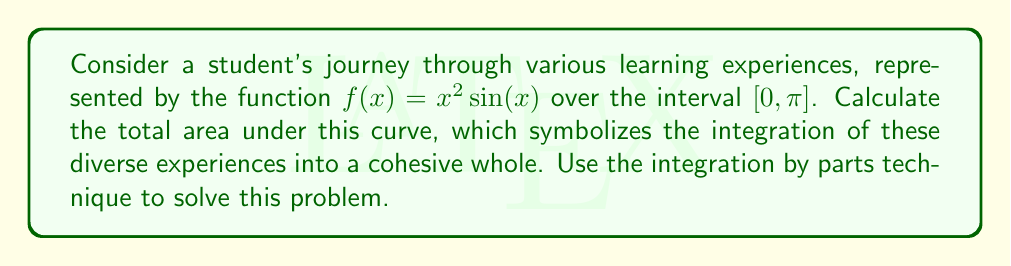Help me with this question. To solve this problem, we'll use integration by parts. The formula for integration by parts is:

$$\int u \frac{dv}{dx} dx = uv - \int v \frac{du}{dx} dx$$

Let's choose:
$u = x^2$ and $\frac{dv}{dx} = \sin(x)$

Then:
$\frac{du}{dx} = 2x$ and $v = -\cos(x)$

Applying the formula:

$$\begin{align*}
\int_0^\pi x^2 \sin(x) dx &= -x^2 \cos(x) \Big|_0^\pi + \int_0^\pi 2x \cos(x) dx \\
&= -\pi^2 \cos(\pi) - (0^2 \cos(0)) + \int_0^\pi 2x \cos(x) dx
\end{align*}$$

Now we need to integrate $2x \cos(x)$. Let's use integration by parts again:

Let $u = 2x$ and $\frac{dv}{dx} = \cos(x)$

Then $\frac{du}{dx} = 2$ and $v = \sin(x)$

$$\begin{align*}
\int_0^\pi 2x \cos(x) dx &= 2x \sin(x) \Big|_0^\pi - \int_0^\pi 2 \sin(x) dx \\
&= 2\pi \sin(\pi) - 2\cdot0 \sin(0) + 2 \cos(x) \Big|_0^\pi \\
&= 0 - (2 \cos(\pi) - 2 \cos(0)) \\
&= 0 - (-2 - 2) = 4
\end{align*}$$

Substituting this back into our original integral:

$$\begin{align*}
\int_0^\pi x^2 \sin(x) dx &= -\pi^2 \cos(\pi) - (0^2 \cos(0)) + 4 \\
&= \pi^2 + 4
\end{align*}$$

This result represents the total area under the curve, symbolizing the integration of diverse experiences into a cohesive whole.
Answer: $\pi^2 + 4$ 